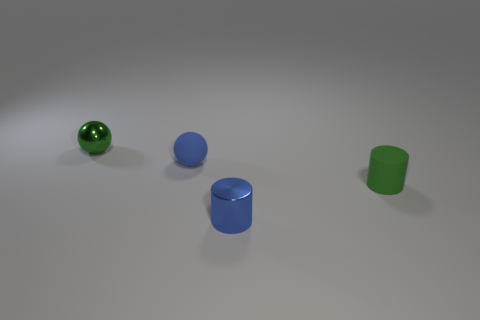Add 1 tiny things. How many objects exist? 5 Subtract all big things. Subtract all tiny shiny balls. How many objects are left? 3 Add 2 small blue metal things. How many small blue metal things are left? 3 Add 2 matte cylinders. How many matte cylinders exist? 3 Subtract 1 blue spheres. How many objects are left? 3 